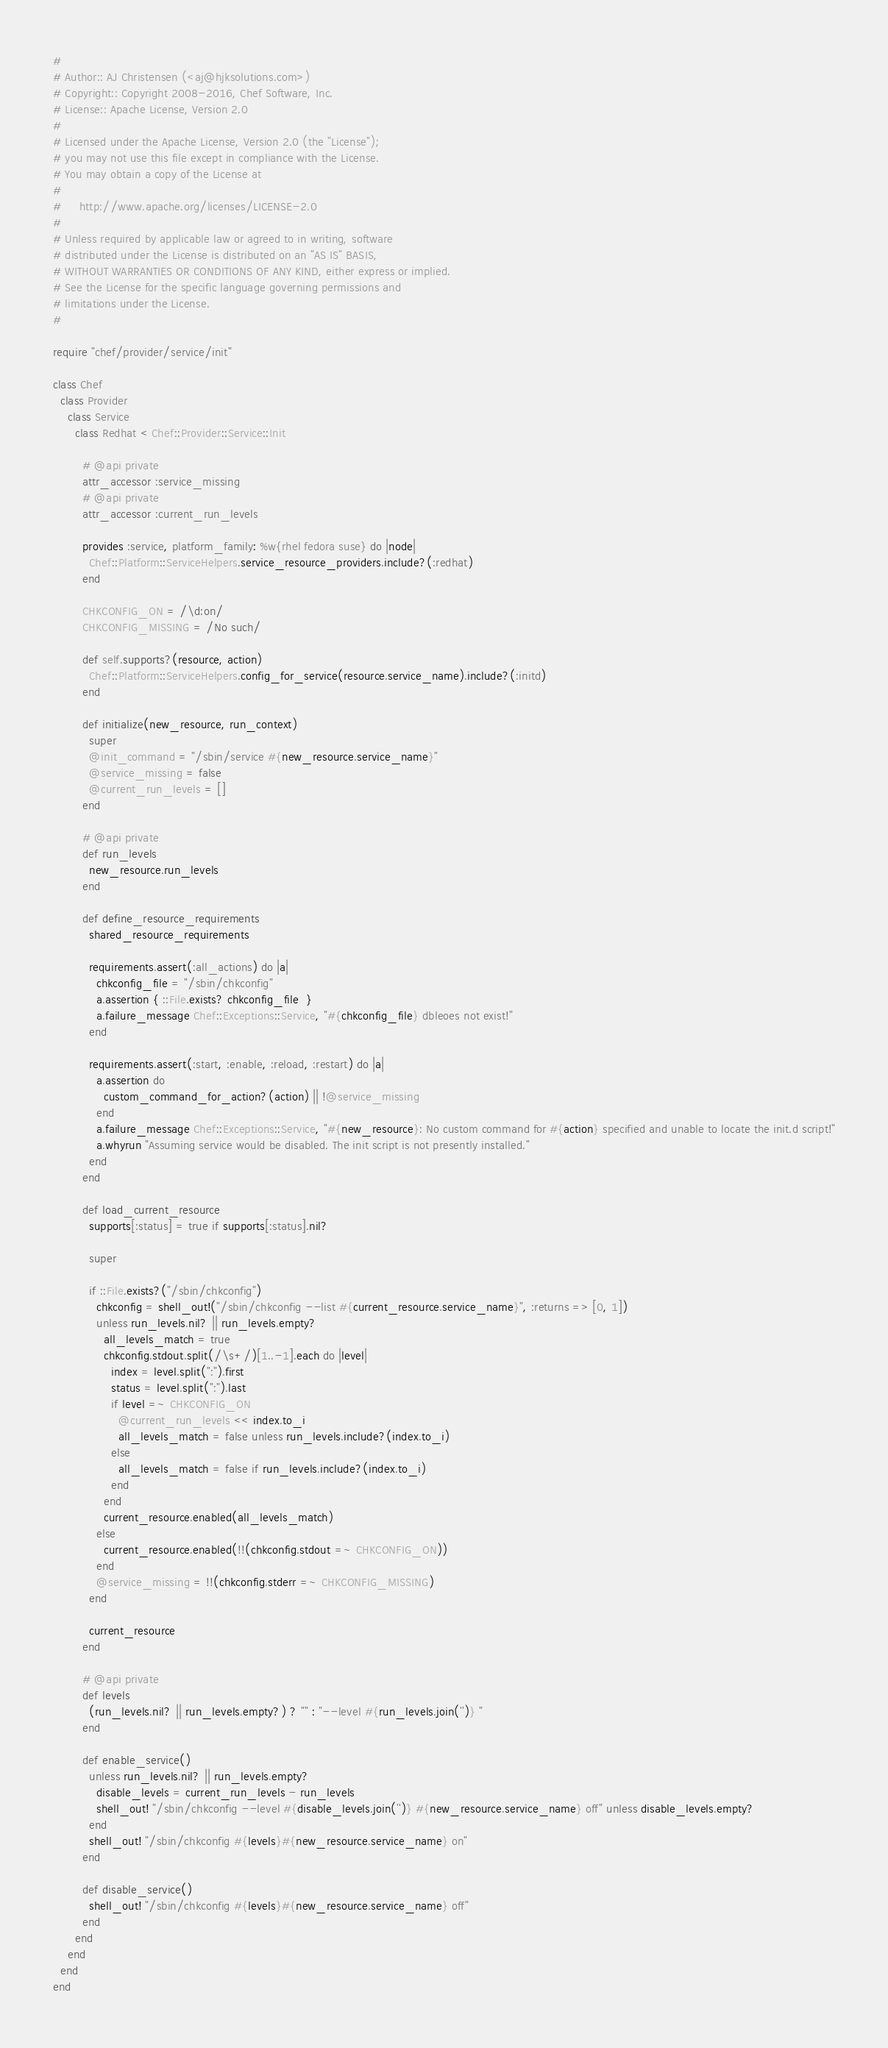Convert code to text. <code><loc_0><loc_0><loc_500><loc_500><_Ruby_>#
# Author:: AJ Christensen (<aj@hjksolutions.com>)
# Copyright:: Copyright 2008-2016, Chef Software, Inc.
# License:: Apache License, Version 2.0
#
# Licensed under the Apache License, Version 2.0 (the "License");
# you may not use this file except in compliance with the License.
# You may obtain a copy of the License at
#
#     http://www.apache.org/licenses/LICENSE-2.0
#
# Unless required by applicable law or agreed to in writing, software
# distributed under the License is distributed on an "AS IS" BASIS,
# WITHOUT WARRANTIES OR CONDITIONS OF ANY KIND, either express or implied.
# See the License for the specific language governing permissions and
# limitations under the License.
#

require "chef/provider/service/init"

class Chef
  class Provider
    class Service
      class Redhat < Chef::Provider::Service::Init

        # @api private
        attr_accessor :service_missing
        # @api private
        attr_accessor :current_run_levels

        provides :service, platform_family: %w{rhel fedora suse} do |node|
          Chef::Platform::ServiceHelpers.service_resource_providers.include?(:redhat)
        end

        CHKCONFIG_ON = /\d:on/
        CHKCONFIG_MISSING = /No such/

        def self.supports?(resource, action)
          Chef::Platform::ServiceHelpers.config_for_service(resource.service_name).include?(:initd)
        end

        def initialize(new_resource, run_context)
          super
          @init_command = "/sbin/service #{new_resource.service_name}"
          @service_missing = false
          @current_run_levels = []
        end

        # @api private
        def run_levels
          new_resource.run_levels
        end

        def define_resource_requirements
          shared_resource_requirements

          requirements.assert(:all_actions) do |a|
            chkconfig_file = "/sbin/chkconfig"
            a.assertion { ::File.exists? chkconfig_file  }
            a.failure_message Chef::Exceptions::Service, "#{chkconfig_file} dbleoes not exist!"
          end

          requirements.assert(:start, :enable, :reload, :restart) do |a|
            a.assertion do
              custom_command_for_action?(action) || !@service_missing
            end
            a.failure_message Chef::Exceptions::Service, "#{new_resource}: No custom command for #{action} specified and unable to locate the init.d script!"
            a.whyrun "Assuming service would be disabled. The init script is not presently installed."
          end
        end

        def load_current_resource
          supports[:status] = true if supports[:status].nil?

          super

          if ::File.exists?("/sbin/chkconfig")
            chkconfig = shell_out!("/sbin/chkconfig --list #{current_resource.service_name}", :returns => [0, 1])
            unless run_levels.nil? || run_levels.empty?
              all_levels_match = true
              chkconfig.stdout.split(/\s+/)[1..-1].each do |level|
                index = level.split(":").first
                status = level.split(":").last
                if level =~ CHKCONFIG_ON
                  @current_run_levels << index.to_i
                  all_levels_match = false unless run_levels.include?(index.to_i)
                else
                  all_levels_match = false if run_levels.include?(index.to_i)
                end
              end
              current_resource.enabled(all_levels_match)
            else
              current_resource.enabled(!!(chkconfig.stdout =~ CHKCONFIG_ON))
            end
            @service_missing = !!(chkconfig.stderr =~ CHKCONFIG_MISSING)
          end

          current_resource
        end

        # @api private
        def levels
          (run_levels.nil? || run_levels.empty?) ? "" : "--level #{run_levels.join('')} "
        end

        def enable_service()
          unless run_levels.nil? || run_levels.empty?
            disable_levels = current_run_levels - run_levels
            shell_out! "/sbin/chkconfig --level #{disable_levels.join('')} #{new_resource.service_name} off" unless disable_levels.empty?
          end
          shell_out! "/sbin/chkconfig #{levels}#{new_resource.service_name} on"
        end

        def disable_service()
          shell_out! "/sbin/chkconfig #{levels}#{new_resource.service_name} off"
        end
      end
    end
  end
end
</code> 